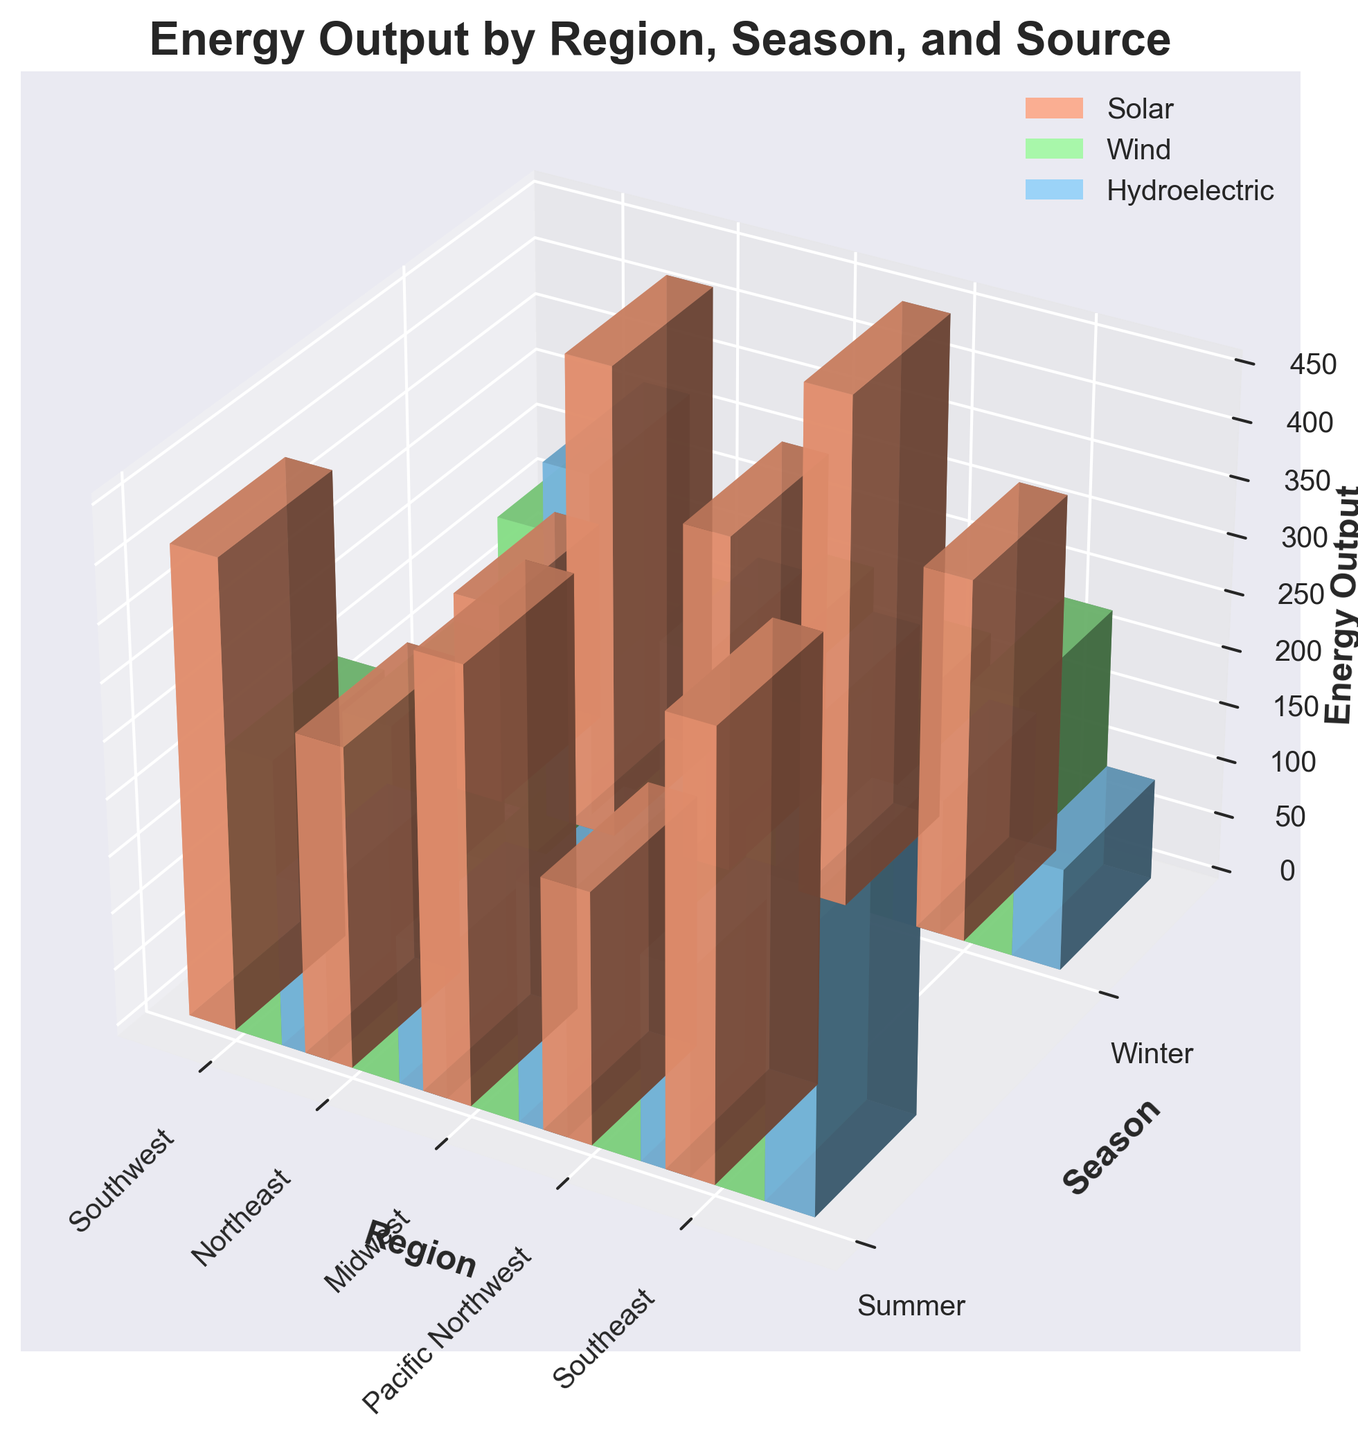What is the title of the 3D bar plot? The title of a plot is typically found at the top and is used to summarize the main focus of the data being visualized. In this case, it emphasizes the type of energy output detailed by region, season, and source.
Answer: Energy Output by Region, Season, and Source Which regions are included in the 3D bar plot? Regions are listed as distinct categories on one of the plot’s axes, specifically along the x-axis, and are referenced frequently in the tick labels.
Answer: Southwest, Northeast, Midwest, Pacific Northwest, Southeast What is the color representing Wind energy output? The color associated with each energy type is shown in the legend of the plot. Wind energy is paired with a specific color.
Answer: Green Which season has the highest solar energy output in the Southwest? To find this, examine the bars for the Southwest region across both seasons and see which one is taller for solar energy.
Answer: Summer Among the Midwest and Pacific Northwest, which region has higher hydroelectric energy output in the winter? Compare the height of the hydroelectric energy bars for Midwest and Pacific Northwest in the winter season.
Answer: Pacific Northwest What is the difference in wind energy output between summer and winter in the Northeast region? Calculate the difference by subtracting the winter wind energy output bar height from the summer wind energy output bar height for the Northeast region.
Answer: 70 Calculate the sum of the hydroelectric energy outputs for the Southeast in both seasons. Add the heights of the hydroelectric bars for the Southeast in both the summer and winter seasons.
Answer: 360 Which season shows higher overall solar energy output in the Midwest region? Compare the solar energy bar heights for the Midwest region in the summer and winter.
Answer: Summer Identify the region and season with the lowest wind energy output. Look for the shortest wind energy output bar across all regions and seasons to identify the corresponding region and season.
Answer: Southeast in Summer Is the energy output from hydroelectric sources higher in winter for the Pacific Northwest compared to the northeast in winter? Compare the height of the hydroelectric bars for both the Pacific Northwest and Northeast regions during winter.
Answer: Yes 